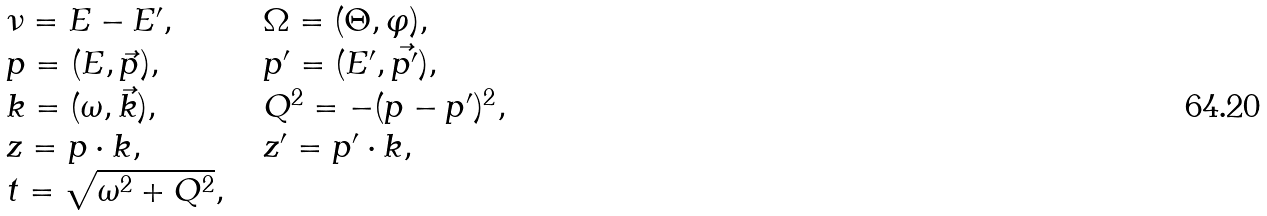<formula> <loc_0><loc_0><loc_500><loc_500>\begin{array} { l l l } \nu = E - E ^ { \prime } , & \, & \Omega = ( \Theta , \varphi ) , \\ p = ( E , \vec { p } ) , & \, & p ^ { \prime } = ( E ^ { \prime } , \vec { p ^ { \prime } } ) , \\ k = ( \omega , \vec { k } ) , & \, & Q ^ { 2 } = - ( p - p ^ { \prime } ) ^ { 2 } , \\ z = p \cdot k , & \, & z ^ { \prime } = p ^ { \prime } \cdot k , \\ t = \sqrt { \omega ^ { 2 } + Q ^ { 2 } } , & & \end{array}</formula> 